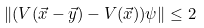Convert formula to latex. <formula><loc_0><loc_0><loc_500><loc_500>\| ( V ( \vec { x } - \vec { y } ) - V ( \vec { x } ) ) \psi \| \leq 2</formula> 